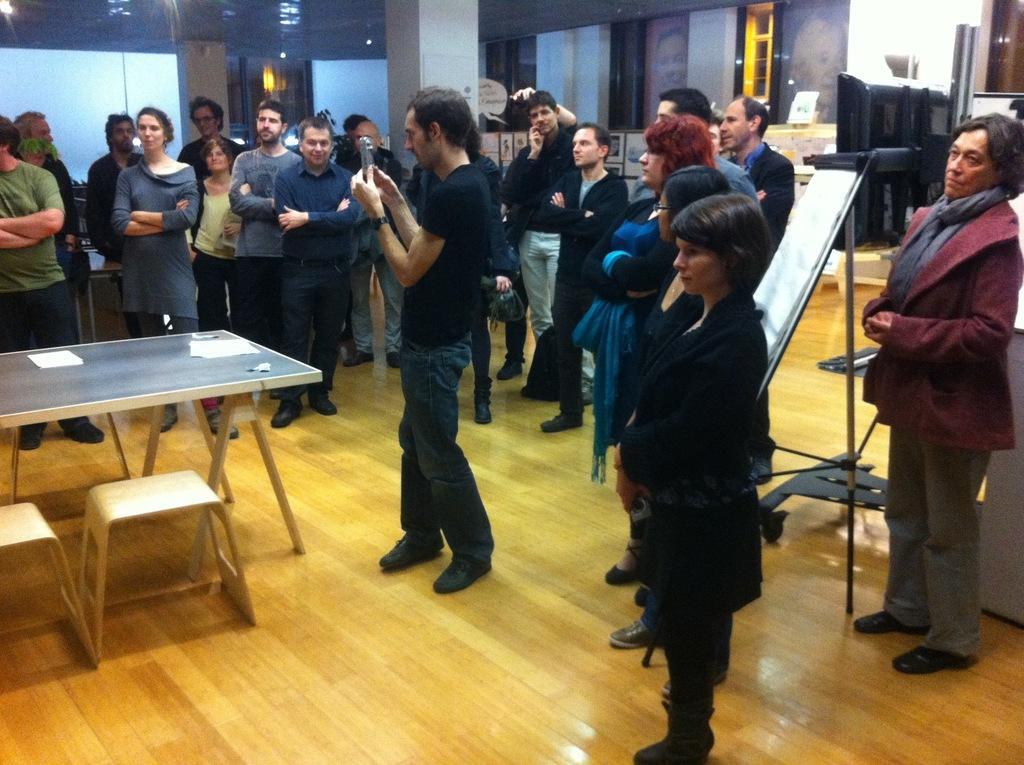Describe this image in one or two sentences. There are many persons standing. A person in the center is holding a camera. On the left side there is a table and stools. In the back there is a stand with board. In the background there are pillar, wall. 